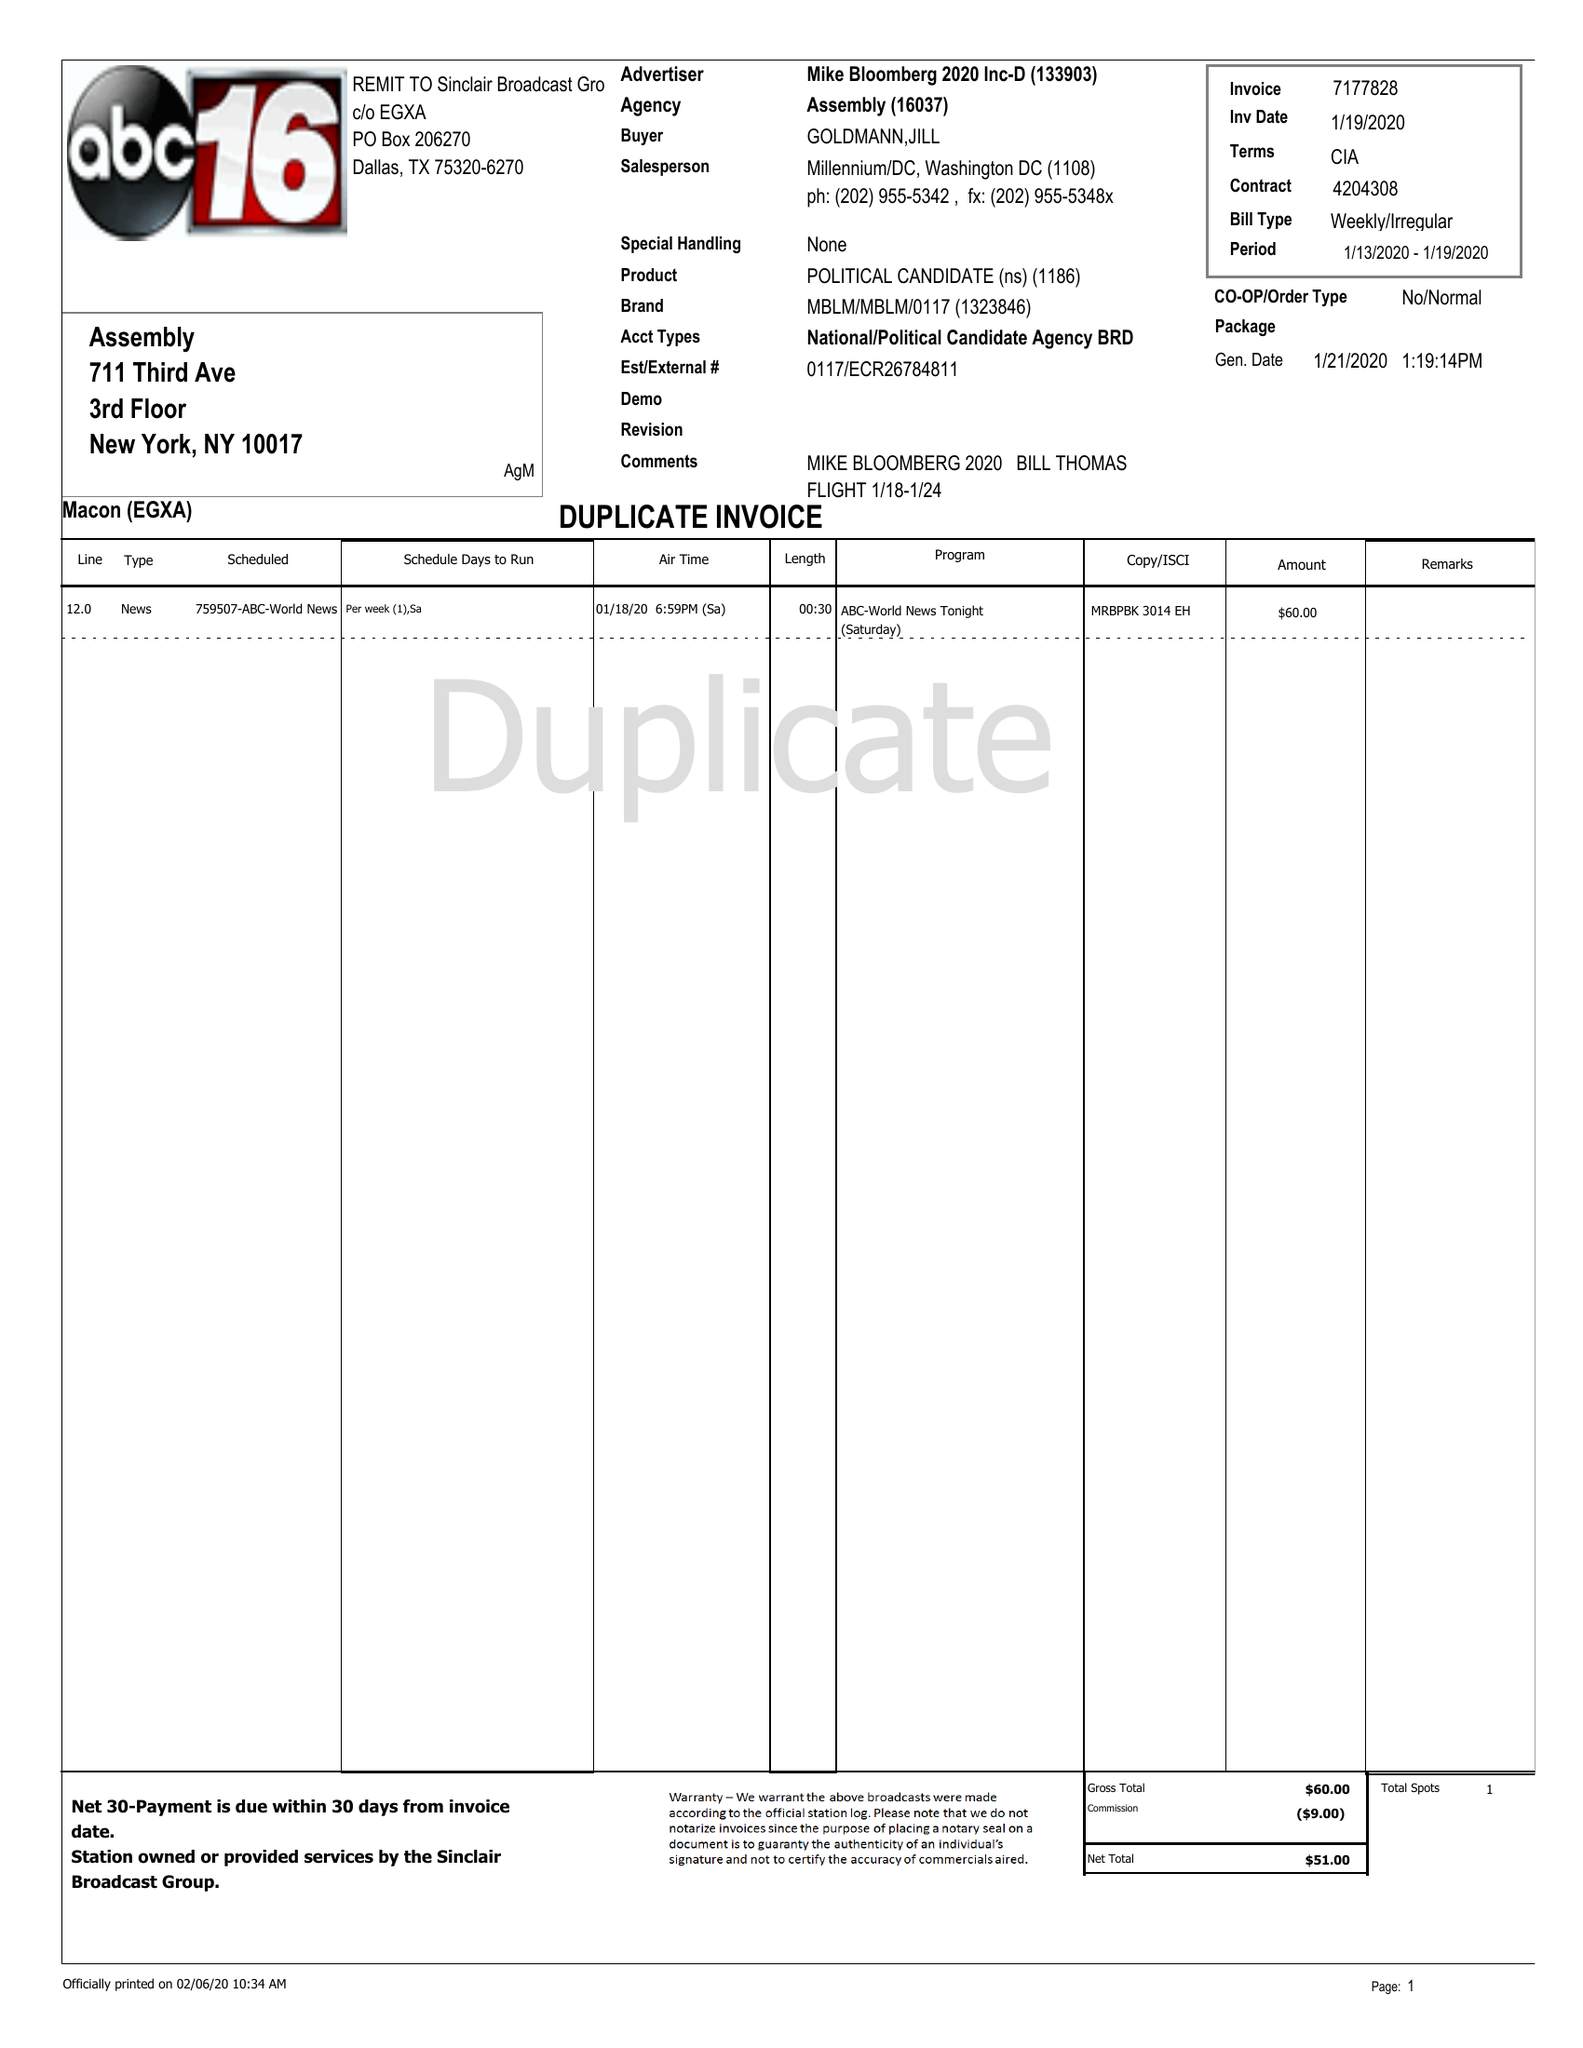What is the value for the gross_amount?
Answer the question using a single word or phrase. 60.00 